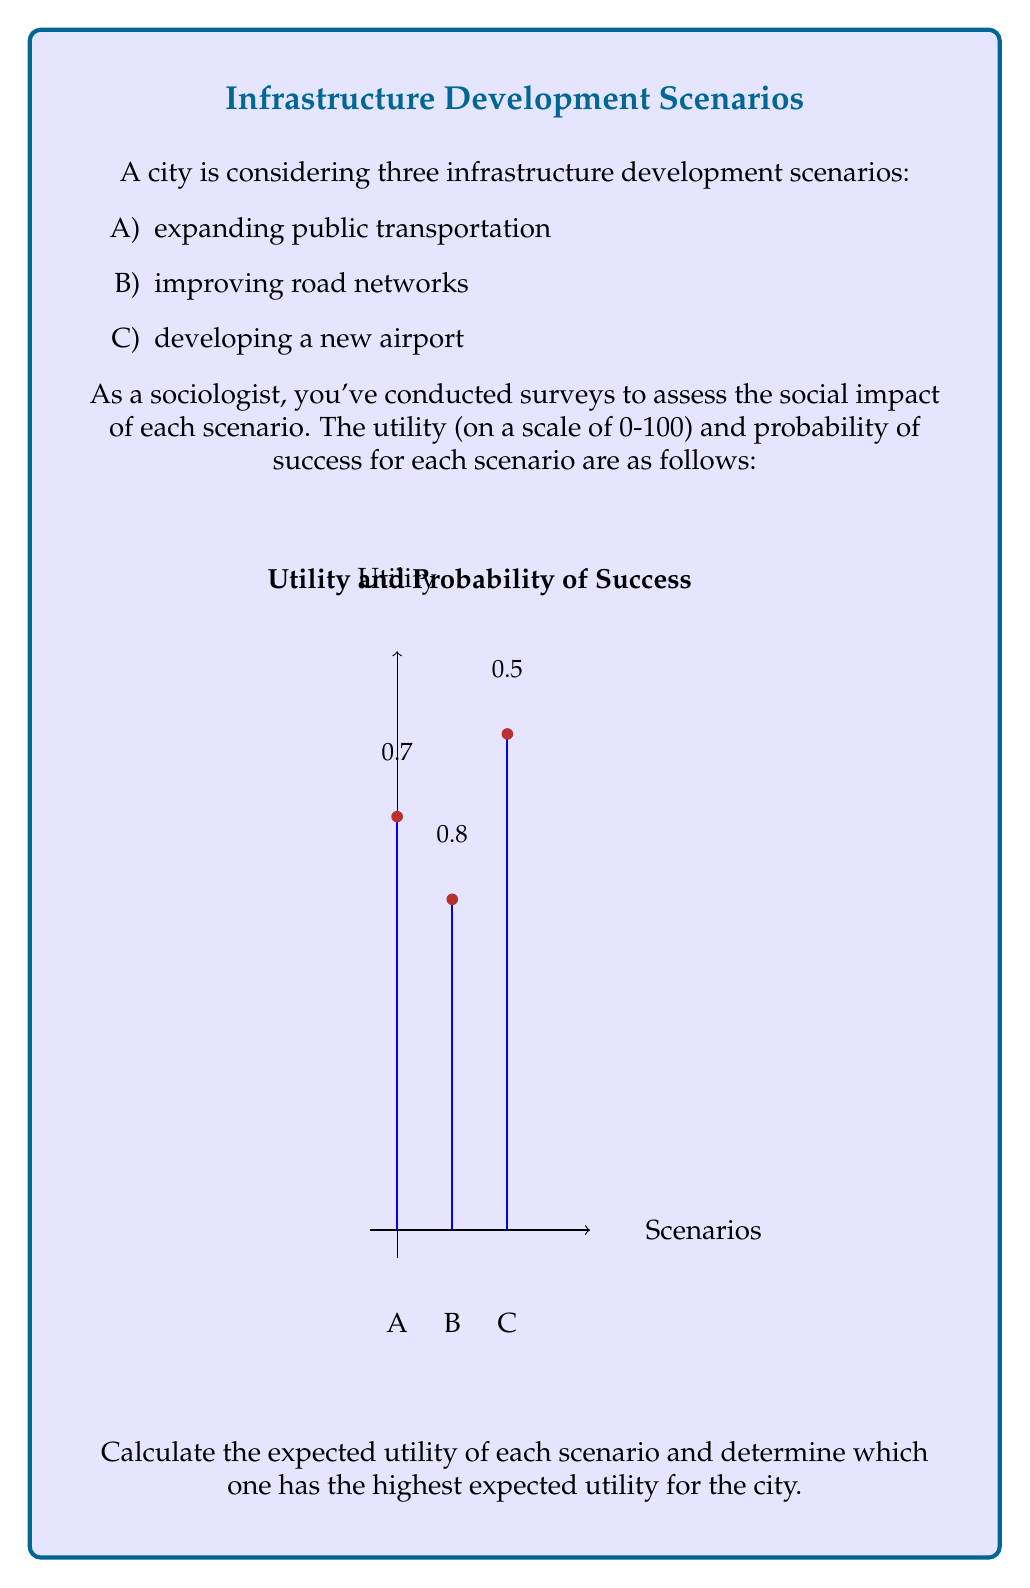Could you help me with this problem? To solve this problem, we need to calculate the expected utility for each scenario and then compare them. The expected utility is calculated by multiplying the utility value by the probability of success.

Let's calculate the expected utility for each scenario:

1. Scenario A (Expanding public transportation):
   Utility = 75, Probability = 0.7
   Expected Utility = $75 \times 0.7 = 52.5$

2. Scenario B (Improving road networks):
   Utility = 60, Probability = 0.8
   Expected Utility = $60 \times 0.8 = 48$

3. Scenario C (Developing a new airport):
   Utility = 90, Probability = 0.5
   Expected Utility = $90 \times 0.5 = 45$

Now, let's compare the expected utilities:

$$\begin{aligned}
E(A) &= 52.5 \\
E(B) &= 48.0 \\
E(C) &= 45.0
\end{aligned}$$

We can see that Scenario A has the highest expected utility at 52.5.

As a sociologist studying the social implications of infrastructure investments, this result suggests that expanding public transportation would likely have the most positive social impact on the city, considering both the potential benefits and the likelihood of successful implementation.
Answer: Scenario A (expanding public transportation) has the highest expected utility of 52.5. 